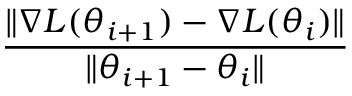<formula> <loc_0><loc_0><loc_500><loc_500>\frac { \| \nabla L ( \theta _ { i + 1 } ) - \nabla L ( \theta _ { i } ) \| } { \| \theta _ { i + 1 } - \theta _ { i } \| }</formula> 